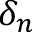Convert formula to latex. <formula><loc_0><loc_0><loc_500><loc_500>\delta _ { n }</formula> 